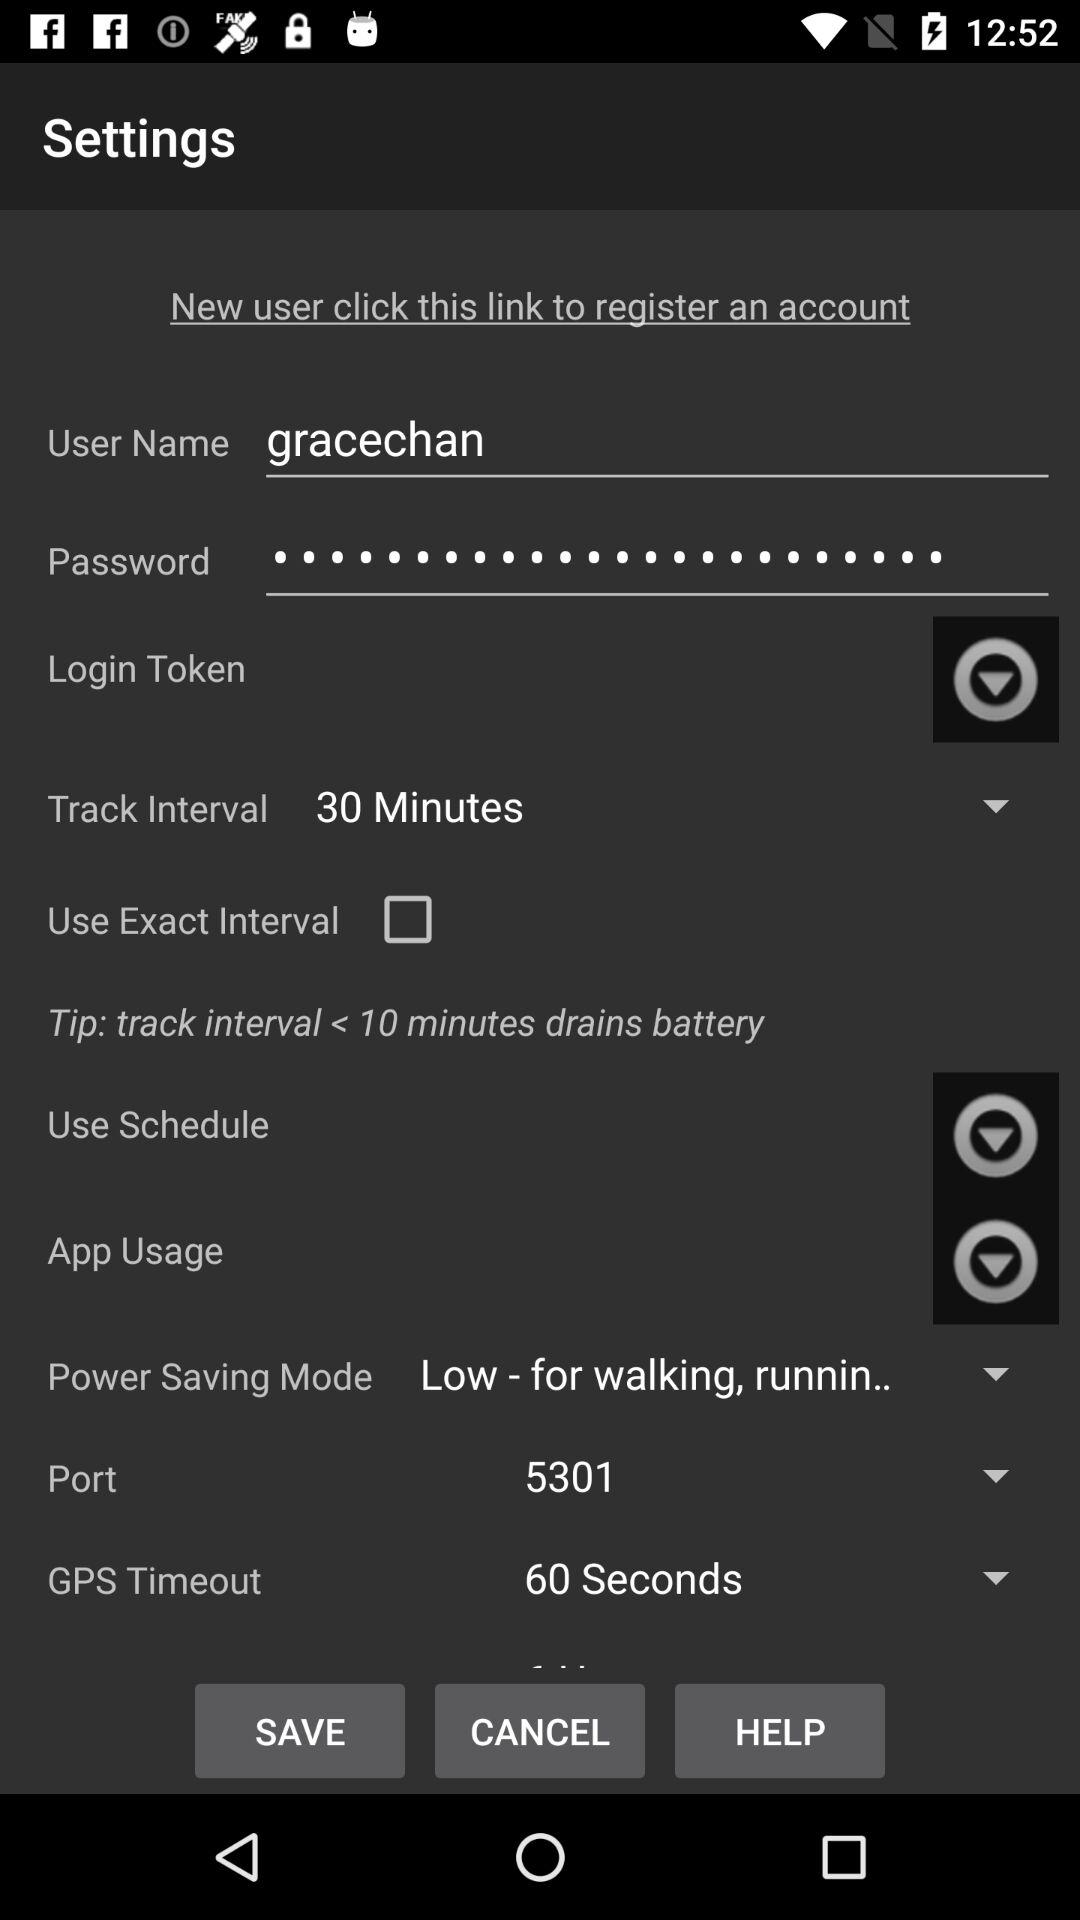What is the username? The username is "gracechan". 